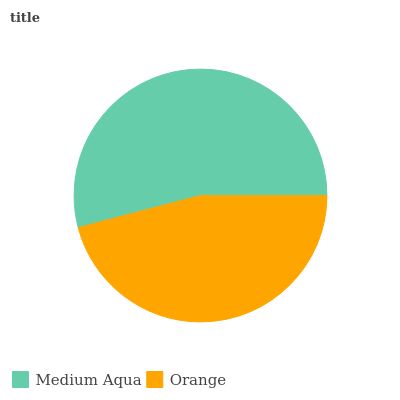Is Orange the minimum?
Answer yes or no. Yes. Is Medium Aqua the maximum?
Answer yes or no. Yes. Is Orange the maximum?
Answer yes or no. No. Is Medium Aqua greater than Orange?
Answer yes or no. Yes. Is Orange less than Medium Aqua?
Answer yes or no. Yes. Is Orange greater than Medium Aqua?
Answer yes or no. No. Is Medium Aqua less than Orange?
Answer yes or no. No. Is Medium Aqua the high median?
Answer yes or no. Yes. Is Orange the low median?
Answer yes or no. Yes. Is Orange the high median?
Answer yes or no. No. Is Medium Aqua the low median?
Answer yes or no. No. 